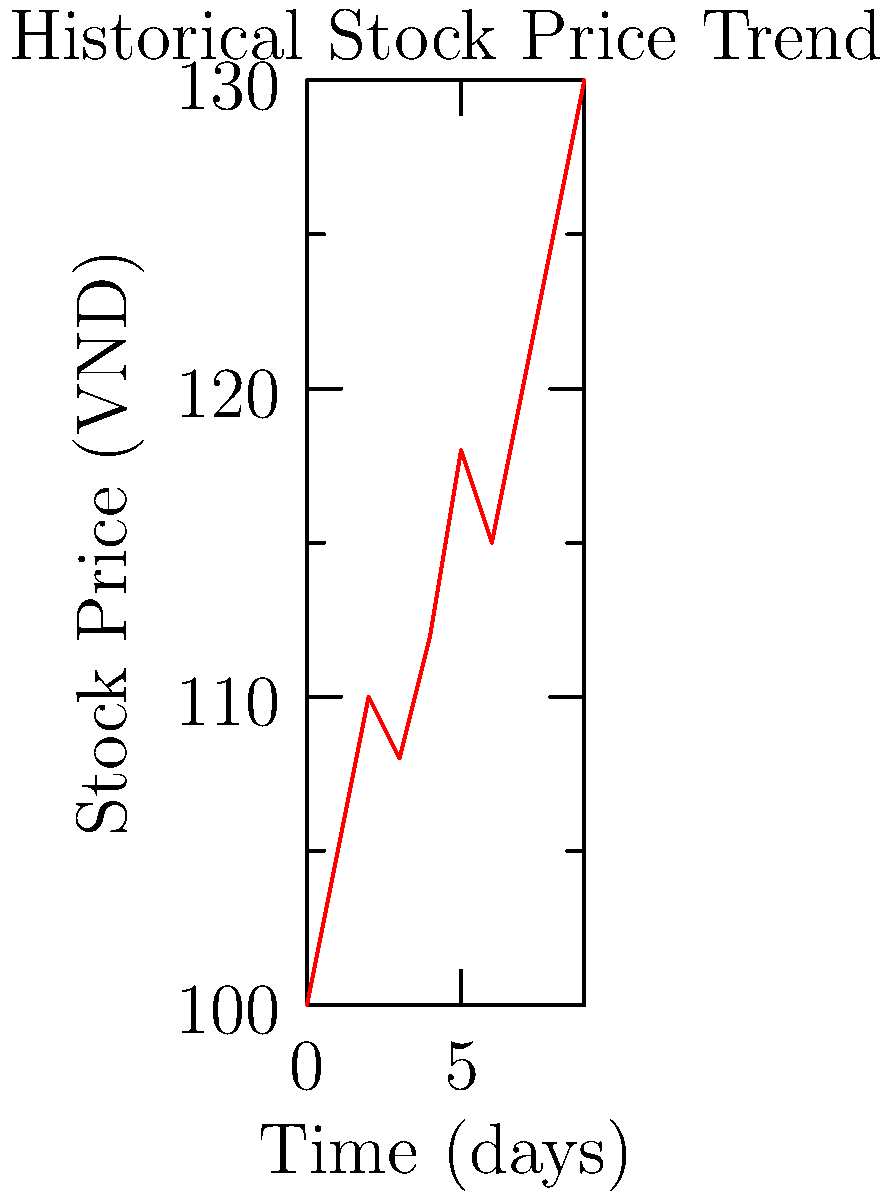Based on the historical stock price trend shown in the line graph, which machine learning technique would be most appropriate for predicting future price movements of this Vietnamese company's stock? To determine the most appropriate machine learning technique for predicting future stock price movements, we need to analyze the given data:

1. Data type: The graph shows a time series of stock prices over 10 days.
2. Pattern: There's a general upward trend with some fluctuations.
3. Complexity: The trend is not perfectly linear, suggesting some non-linear components.
4. Time dependency: Stock prices often depend on previous values.

Given these characteristics:

1. Linear Regression would be too simplistic for this data, as it can't capture the non-linear components.
2. Decision Trees or Random Forests might struggle with the continuous nature of time series data.
3. Support Vector Machines could work but may not fully capture the time-dependent nature of the data.
4. Neural Networks, particularly Recurrent Neural Networks (RNNs) or Long Short-Term Memory (LSTM) networks, are well-suited for time series prediction and can capture both linear and non-linear patterns.

Therefore, the most appropriate technique would be a type of Recurrent Neural Network, such as LSTM, which is specifically designed to handle sequential data and can capture long-term dependencies in time series.
Answer: Recurrent Neural Network (RNN) or Long Short-Term Memory (LSTM) network 